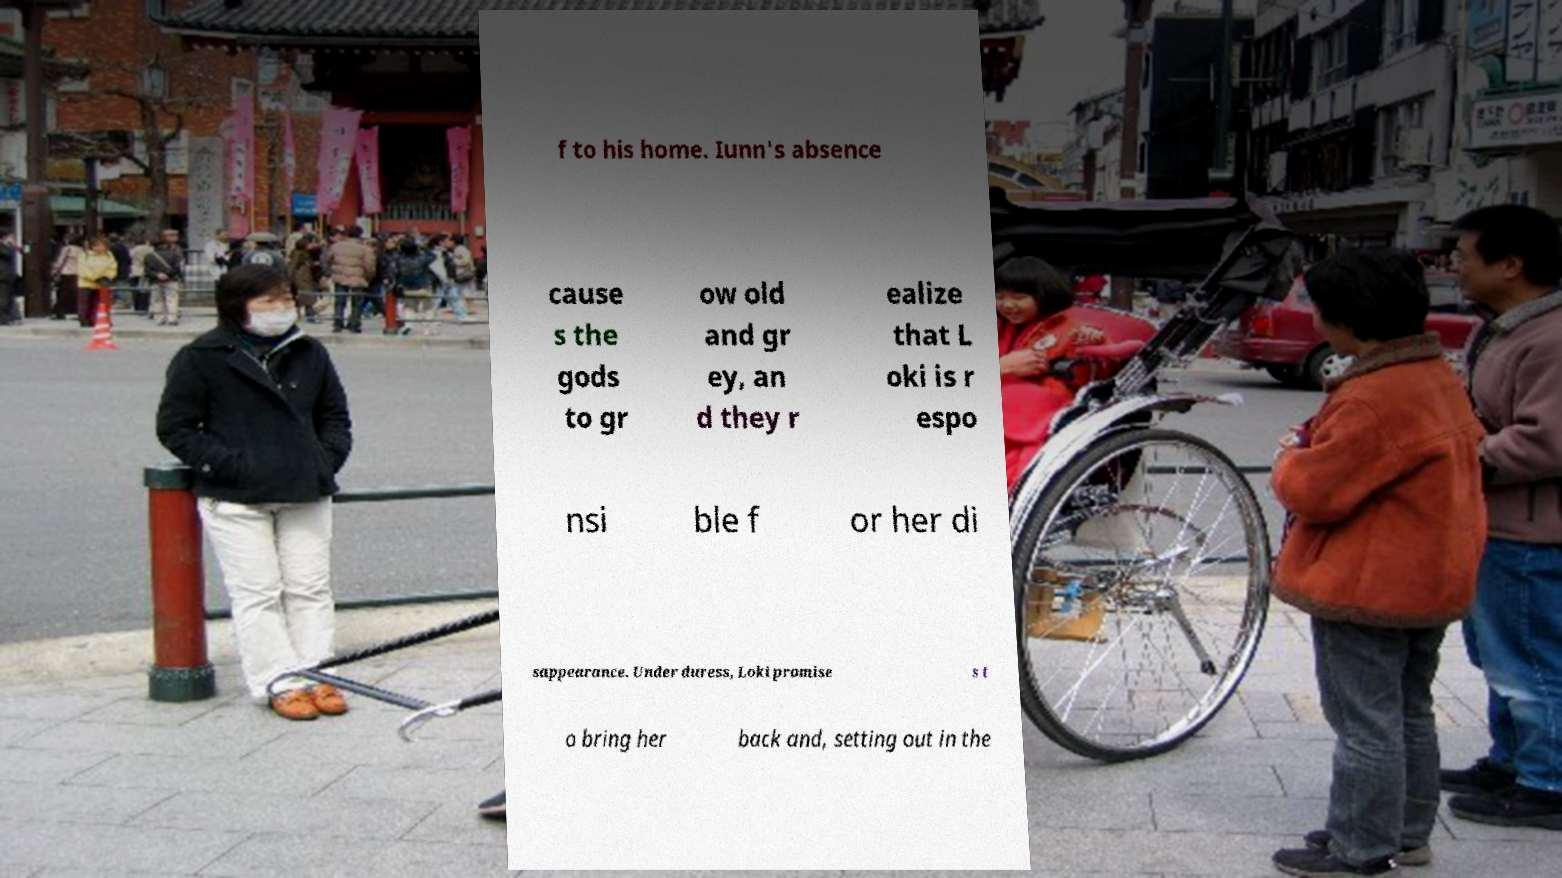Please read and relay the text visible in this image. What does it say? f to his home. Iunn's absence cause s the gods to gr ow old and gr ey, an d they r ealize that L oki is r espo nsi ble f or her di sappearance. Under duress, Loki promise s t o bring her back and, setting out in the 